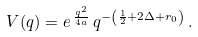Convert formula to latex. <formula><loc_0><loc_0><loc_500><loc_500>V ( q ) = e \, ^ { \frac { q ^ { 2 } } { 4 a } } \, q ^ { - \left ( \frac { 1 } { 2 } + 2 \Delta + r _ { 0 } \right ) } \, .</formula> 